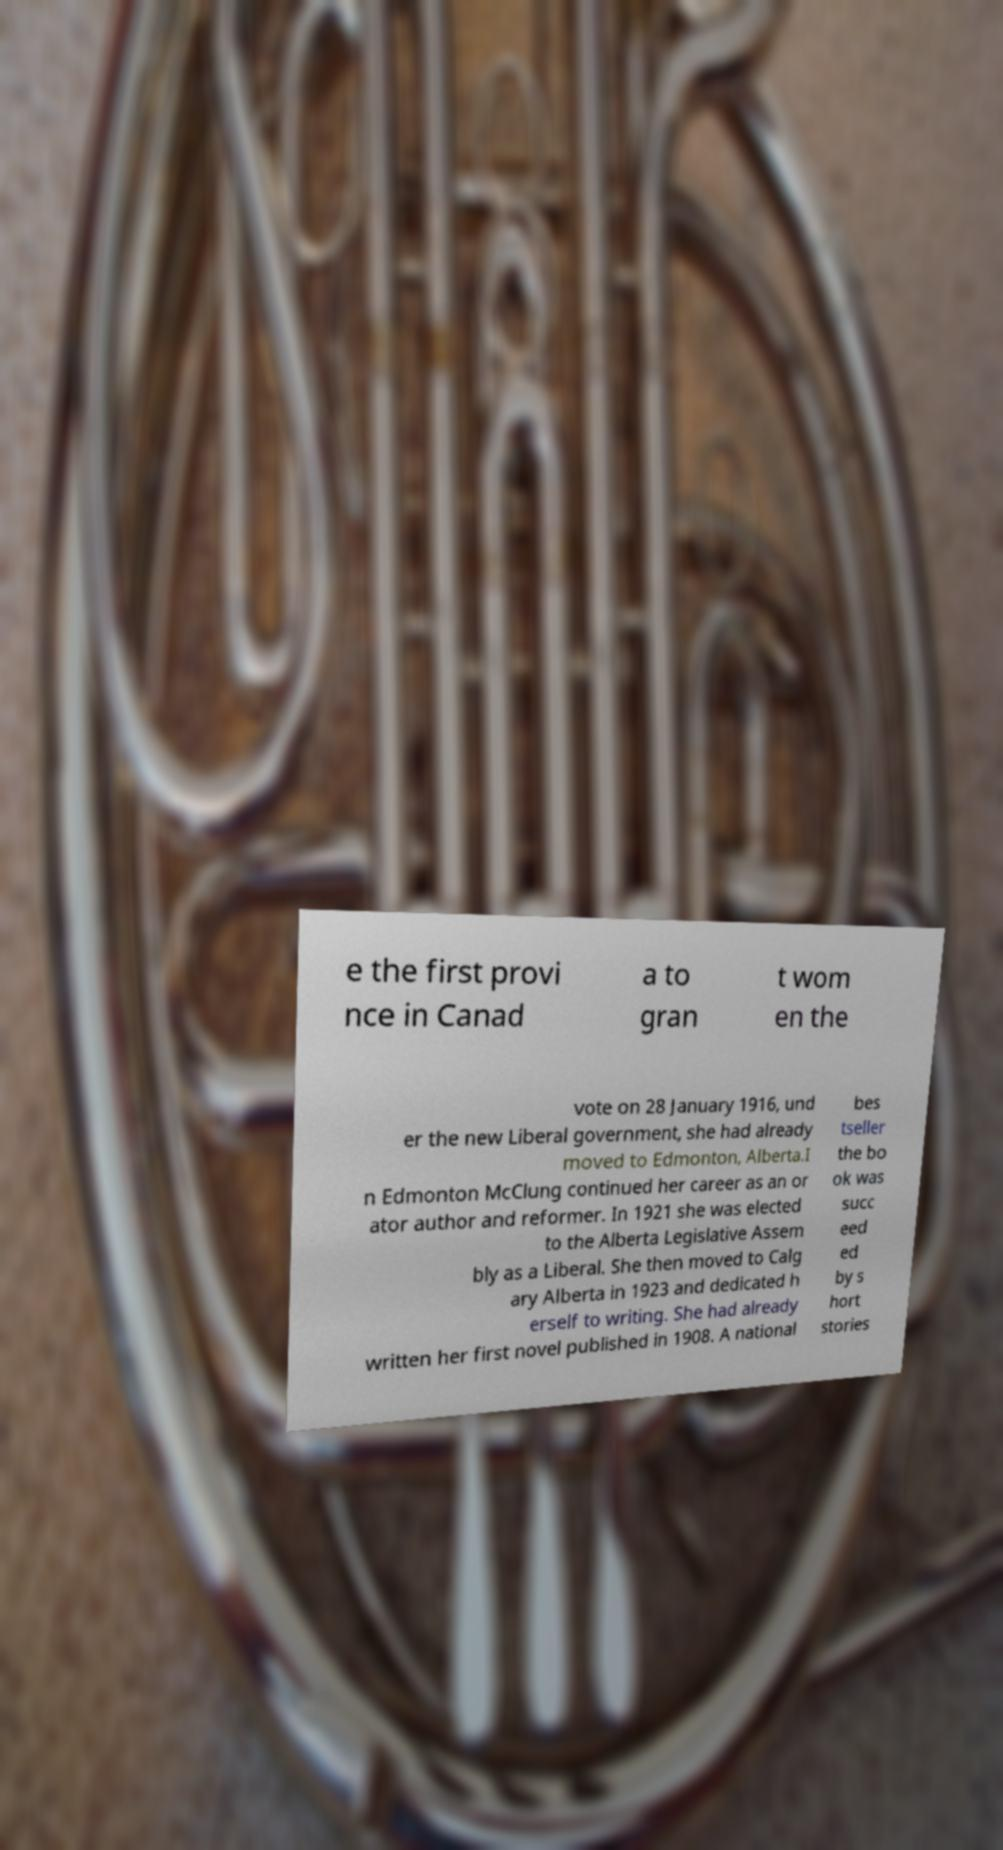What messages or text are displayed in this image? I need them in a readable, typed format. e the first provi nce in Canad a to gran t wom en the vote on 28 January 1916, und er the new Liberal government, she had already moved to Edmonton, Alberta.I n Edmonton McClung continued her career as an or ator author and reformer. In 1921 she was elected to the Alberta Legislative Assem bly as a Liberal. She then moved to Calg ary Alberta in 1923 and dedicated h erself to writing. She had already written her first novel published in 1908. A national bes tseller the bo ok was succ eed ed by s hort stories 